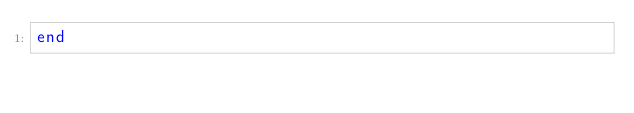<code> <loc_0><loc_0><loc_500><loc_500><_Ruby_>end</code> 